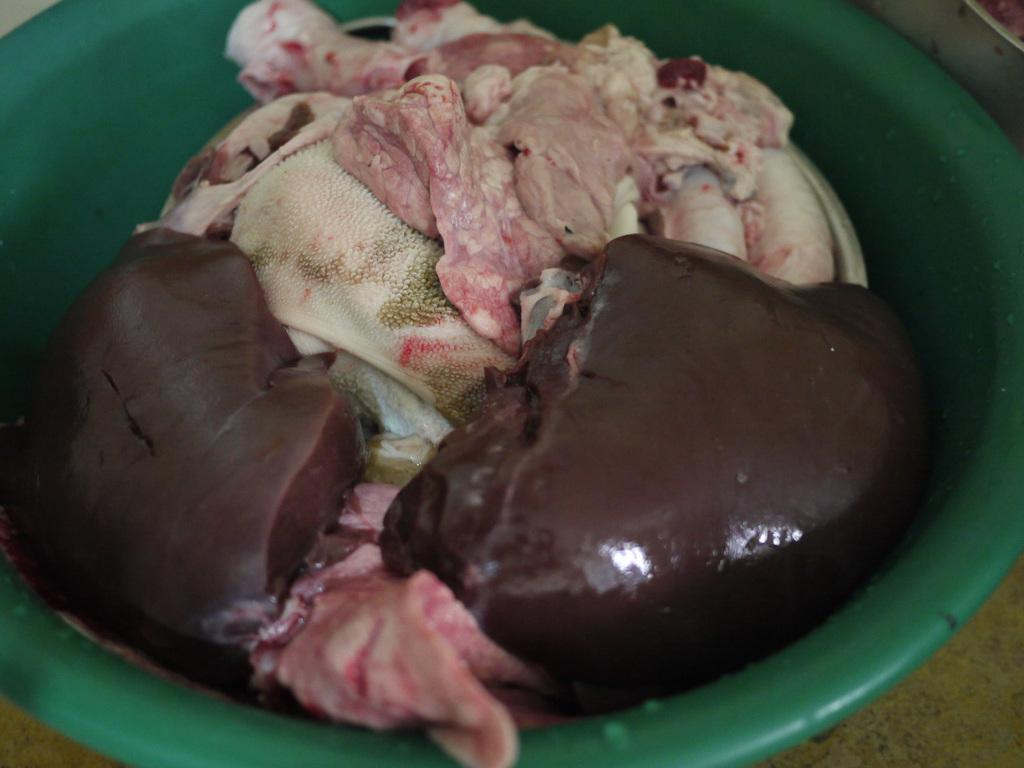What type of food is present in the image? There is meat in the image. In what type of bowl is the meat placed? The meat is in a green color bowl. Can you describe the appearance of the meat? The meat has a cream and brown color. What type of train can be seen in the image? There is no train present in the image; it features meat in a green color bowl. 